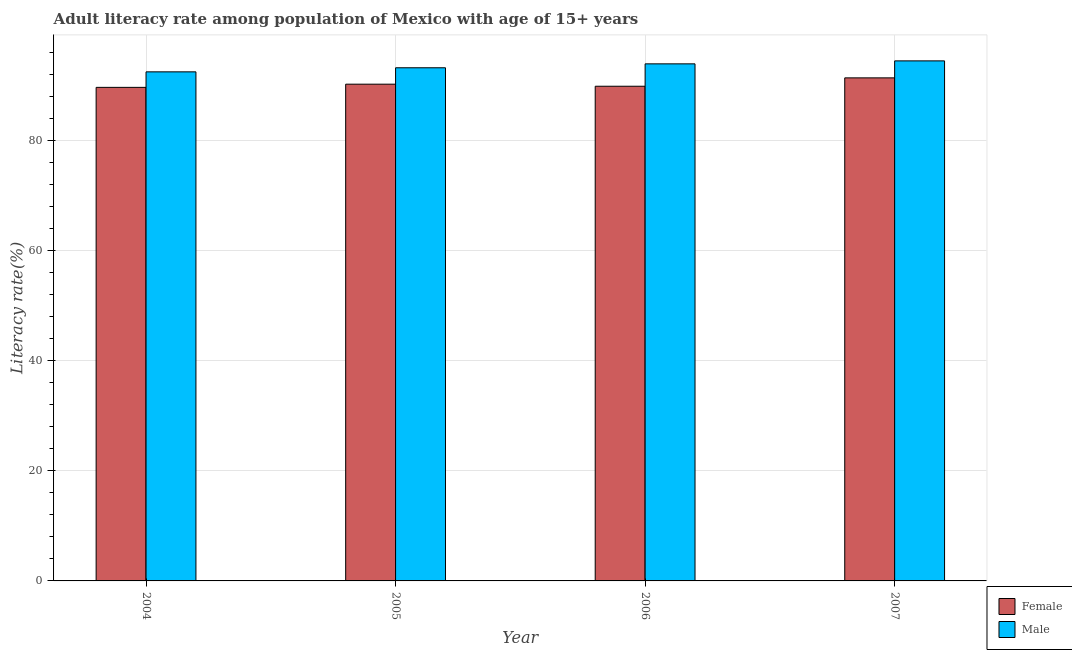How many different coloured bars are there?
Give a very brief answer. 2. How many groups of bars are there?
Make the answer very short. 4. Are the number of bars on each tick of the X-axis equal?
Your answer should be very brief. Yes. How many bars are there on the 2nd tick from the left?
Provide a short and direct response. 2. What is the label of the 1st group of bars from the left?
Ensure brevity in your answer.  2004. In how many cases, is the number of bars for a given year not equal to the number of legend labels?
Provide a short and direct response. 0. What is the female adult literacy rate in 2007?
Ensure brevity in your answer.  91.36. Across all years, what is the maximum male adult literacy rate?
Make the answer very short. 94.44. Across all years, what is the minimum female adult literacy rate?
Give a very brief answer. 89.63. In which year was the female adult literacy rate minimum?
Your answer should be compact. 2004. What is the total male adult literacy rate in the graph?
Offer a terse response. 373.98. What is the difference between the female adult literacy rate in 2006 and that in 2007?
Your answer should be very brief. -1.52. What is the difference between the female adult literacy rate in 2005 and the male adult literacy rate in 2007?
Provide a short and direct response. -1.15. What is the average female adult literacy rate per year?
Your answer should be compact. 90.26. In the year 2005, what is the difference between the male adult literacy rate and female adult literacy rate?
Your answer should be compact. 0. In how many years, is the male adult literacy rate greater than 32 %?
Make the answer very short. 4. What is the ratio of the female adult literacy rate in 2006 to that in 2007?
Your response must be concise. 0.98. Is the difference between the female adult literacy rate in 2006 and 2007 greater than the difference between the male adult literacy rate in 2006 and 2007?
Provide a short and direct response. No. What is the difference between the highest and the second highest male adult literacy rate?
Offer a terse response. 0.54. What is the difference between the highest and the lowest female adult literacy rate?
Provide a succinct answer. 1.72. What does the 2nd bar from the left in 2006 represents?
Offer a terse response. Male. How many years are there in the graph?
Keep it short and to the point. 4. What is the difference between two consecutive major ticks on the Y-axis?
Offer a terse response. 20. Does the graph contain grids?
Give a very brief answer. Yes. How many legend labels are there?
Ensure brevity in your answer.  2. How are the legend labels stacked?
Keep it short and to the point. Vertical. What is the title of the graph?
Offer a very short reply. Adult literacy rate among population of Mexico with age of 15+ years. Does "Taxes on exports" appear as one of the legend labels in the graph?
Give a very brief answer. No. What is the label or title of the Y-axis?
Offer a terse response. Literacy rate(%). What is the Literacy rate(%) of Female in 2004?
Offer a terse response. 89.63. What is the Literacy rate(%) in Male in 2004?
Your response must be concise. 92.45. What is the Literacy rate(%) in Female in 2005?
Provide a succinct answer. 90.21. What is the Literacy rate(%) of Male in 2005?
Give a very brief answer. 93.19. What is the Literacy rate(%) of Female in 2006?
Provide a short and direct response. 89.83. What is the Literacy rate(%) of Male in 2006?
Make the answer very short. 93.9. What is the Literacy rate(%) in Female in 2007?
Your response must be concise. 91.36. What is the Literacy rate(%) of Male in 2007?
Make the answer very short. 94.44. Across all years, what is the maximum Literacy rate(%) of Female?
Provide a short and direct response. 91.36. Across all years, what is the maximum Literacy rate(%) in Male?
Ensure brevity in your answer.  94.44. Across all years, what is the minimum Literacy rate(%) of Female?
Your response must be concise. 89.63. Across all years, what is the minimum Literacy rate(%) of Male?
Offer a very short reply. 92.45. What is the total Literacy rate(%) in Female in the graph?
Ensure brevity in your answer.  361.03. What is the total Literacy rate(%) in Male in the graph?
Your answer should be compact. 373.98. What is the difference between the Literacy rate(%) of Female in 2004 and that in 2005?
Your answer should be very brief. -0.58. What is the difference between the Literacy rate(%) of Male in 2004 and that in 2005?
Keep it short and to the point. -0.74. What is the difference between the Literacy rate(%) of Female in 2004 and that in 2006?
Your answer should be compact. -0.2. What is the difference between the Literacy rate(%) of Male in 2004 and that in 2006?
Offer a very short reply. -1.45. What is the difference between the Literacy rate(%) in Female in 2004 and that in 2007?
Give a very brief answer. -1.72. What is the difference between the Literacy rate(%) in Male in 2004 and that in 2007?
Ensure brevity in your answer.  -1.99. What is the difference between the Literacy rate(%) in Female in 2005 and that in 2006?
Make the answer very short. 0.38. What is the difference between the Literacy rate(%) in Male in 2005 and that in 2006?
Keep it short and to the point. -0.71. What is the difference between the Literacy rate(%) of Female in 2005 and that in 2007?
Make the answer very short. -1.15. What is the difference between the Literacy rate(%) of Male in 2005 and that in 2007?
Make the answer very short. -1.25. What is the difference between the Literacy rate(%) of Female in 2006 and that in 2007?
Your response must be concise. -1.52. What is the difference between the Literacy rate(%) of Male in 2006 and that in 2007?
Your answer should be compact. -0.54. What is the difference between the Literacy rate(%) in Female in 2004 and the Literacy rate(%) in Male in 2005?
Give a very brief answer. -3.56. What is the difference between the Literacy rate(%) of Female in 2004 and the Literacy rate(%) of Male in 2006?
Provide a short and direct response. -4.27. What is the difference between the Literacy rate(%) in Female in 2004 and the Literacy rate(%) in Male in 2007?
Offer a very short reply. -4.81. What is the difference between the Literacy rate(%) of Female in 2005 and the Literacy rate(%) of Male in 2006?
Offer a very short reply. -3.69. What is the difference between the Literacy rate(%) of Female in 2005 and the Literacy rate(%) of Male in 2007?
Make the answer very short. -4.23. What is the difference between the Literacy rate(%) of Female in 2006 and the Literacy rate(%) of Male in 2007?
Provide a succinct answer. -4.61. What is the average Literacy rate(%) of Female per year?
Offer a very short reply. 90.26. What is the average Literacy rate(%) in Male per year?
Your answer should be very brief. 93.5. In the year 2004, what is the difference between the Literacy rate(%) in Female and Literacy rate(%) in Male?
Keep it short and to the point. -2.82. In the year 2005, what is the difference between the Literacy rate(%) in Female and Literacy rate(%) in Male?
Provide a short and direct response. -2.98. In the year 2006, what is the difference between the Literacy rate(%) in Female and Literacy rate(%) in Male?
Give a very brief answer. -4.07. In the year 2007, what is the difference between the Literacy rate(%) in Female and Literacy rate(%) in Male?
Provide a short and direct response. -3.09. What is the ratio of the Literacy rate(%) of Female in 2004 to that in 2005?
Provide a short and direct response. 0.99. What is the ratio of the Literacy rate(%) in Male in 2004 to that in 2005?
Your answer should be compact. 0.99. What is the ratio of the Literacy rate(%) in Male in 2004 to that in 2006?
Offer a very short reply. 0.98. What is the ratio of the Literacy rate(%) in Female in 2004 to that in 2007?
Provide a succinct answer. 0.98. What is the ratio of the Literacy rate(%) of Male in 2004 to that in 2007?
Your answer should be compact. 0.98. What is the ratio of the Literacy rate(%) of Female in 2005 to that in 2006?
Ensure brevity in your answer.  1. What is the ratio of the Literacy rate(%) in Female in 2005 to that in 2007?
Offer a terse response. 0.99. What is the ratio of the Literacy rate(%) of Female in 2006 to that in 2007?
Your answer should be very brief. 0.98. What is the difference between the highest and the second highest Literacy rate(%) of Female?
Your response must be concise. 1.15. What is the difference between the highest and the second highest Literacy rate(%) of Male?
Give a very brief answer. 0.54. What is the difference between the highest and the lowest Literacy rate(%) of Female?
Make the answer very short. 1.72. What is the difference between the highest and the lowest Literacy rate(%) of Male?
Make the answer very short. 1.99. 